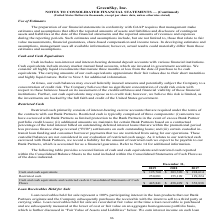According to Greensky's financial document, What does Cash include? non-interest and interest-bearing demand deposit accounts with various financial institutions.. The document states: "Cash includes non-interest and interest-bearing demand deposit accounts with various financial institutions. Cash equivalents include money market mut..." Also, What was the amount of restricted cash in 2017? According to the financial document, 129,224 (in thousands). The relevant text states: "303,390 $ 224,614 Restricted cash 250,081 155,109 129,224 Cash and cash equivalents and restricted cash in Consolidated Statements of Cash Flows $ 445,841 $..." Also, Which years does the table provide? The document contains multiple relevant values: 2019, 2018, 2017. From the document: "December 31, 2019 2018 2017 Cash and cash equivalents $ 195,760 $ 303,390 $ 224,614 Restricted cash 250,081 155,109 129,224 Cas December 31, 2019 2018..." Also, How many years did Cash and cash equivalents and restricted cash in Consolidated Statements of Cash Flows exceed $400,000 thousand? Counting the relevant items in the document: 2019, 2018, I find 2 instances. The key data points involved are: 2018, 2019. Also, can you calculate: What was the change in Cash and cash equivalents between 2018 and 2019? Based on the calculation: 195,760-303,390, the result is -107630 (in thousands). This is based on the information: "9 2018 2017 Cash and cash equivalents $ 195,760 $ 303,390 $ 224,614 Restricted cash 250,081 155,109 129,224 Cash and cash equivalents and restricted cash in er 31, 2019 2018 2017 Cash and cash equival..." The key data points involved are: 195,760, 303,390. Also, can you calculate: What was the percentage change in restricted cash between 2017 and 2018? To answer this question, I need to perform calculations using the financial data. The calculation is: (155,109-129,224)/129,224, which equals 20.03 (percentage). This is based on the information: "5,760 $ 303,390 $ 224,614 Restricted cash 250,081 155,109 129,224 Cash and cash equivalents and restricted cash in Consolidated Statements of Cash Flows $ 44 303,390 $ 224,614 Restricted cash 250,081 ..." The key data points involved are: 129,224, 155,109. 